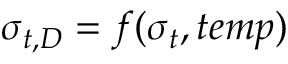<formula> <loc_0><loc_0><loc_500><loc_500>\sigma _ { t , D } = f ( \sigma _ { t } , t e m p )</formula> 